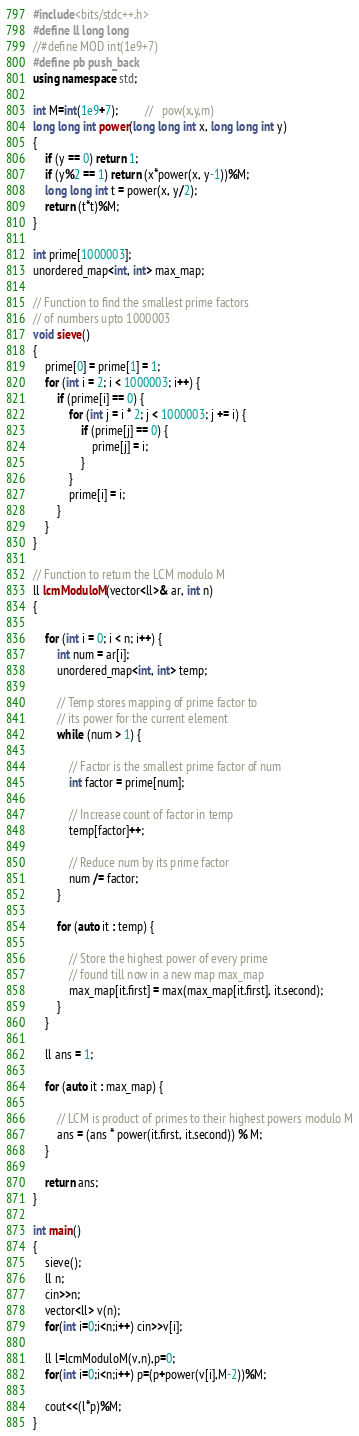Convert code to text. <code><loc_0><loc_0><loc_500><loc_500><_C++_>#include<bits/stdc++.h>
#define ll long long
//#define MOD int(1e9+7)
#define pb push_back
using namespace std;

int M=int(1e9+7);         //   pow(x,y,m)
long long int power(long long int x, long long int y)
{
    if (y == 0) return 1;
    if (y%2 == 1) return (x*power(x, y-1))%M;
    long long int t = power(x, y/2);
    return (t*t)%M;
}

int prime[1000003];
unordered_map<int, int> max_map;

// Function to find the smallest prime factors
// of numbers upto 1000003
void sieve()
{
    prime[0] = prime[1] = 1;
    for (int i = 2; i < 1000003; i++) {
        if (prime[i] == 0) {
            for (int j = i * 2; j < 1000003; j += i) {
                if (prime[j] == 0) {
                    prime[j] = i;
                }
            }
            prime[i] = i;
        }
    }
}

// Function to return the LCM modulo M
ll lcmModuloM(vector<ll>& ar, int n)
{

    for (int i = 0; i < n; i++) {
        int num = ar[i];
        unordered_map<int, int> temp;

        // Temp stores mapping of prime factor to
        // its power for the current element
        while (num > 1) {

            // Factor is the smallest prime factor of num
            int factor = prime[num];

            // Increase count of factor in temp
            temp[factor]++;

            // Reduce num by its prime factor
            num /= factor;
        }

        for (auto it : temp) {

            // Store the highest power of every prime
            // found till now in a new map max_map
            max_map[it.first] = max(max_map[it.first], it.second);
        }
    }

    ll ans = 1;

    for (auto it : max_map) {

        // LCM is product of primes to their highest powers modulo M
        ans = (ans * power(it.first, it.second)) % M;
    }

    return ans;
}

int main()
{
    sieve();
    ll n;
    cin>>n;
    vector<ll> v(n);
    for(int i=0;i<n;i++) cin>>v[i];

    ll l=lcmModuloM(v,n),p=0;
    for(int i=0;i<n;i++) p=(p+power(v[i],M-2))%M;

    cout<<(l*p)%M;
}

</code> 